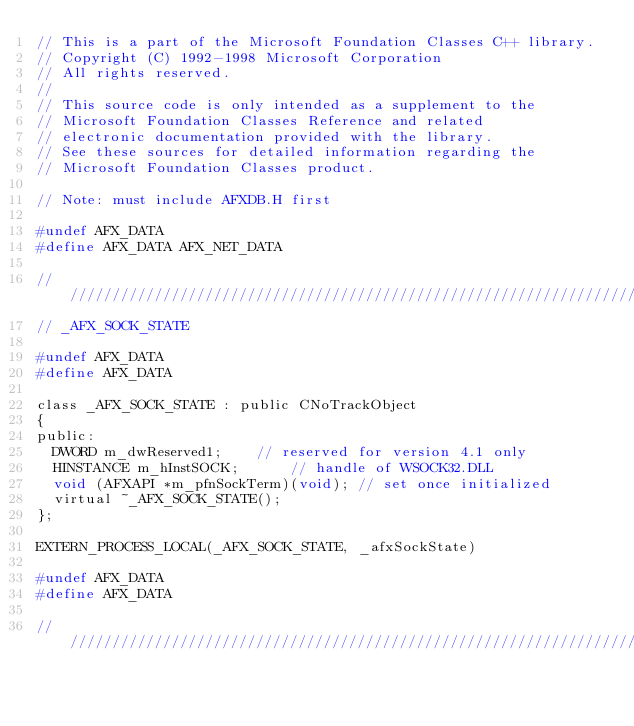<code> <loc_0><loc_0><loc_500><loc_500><_C_>// This is a part of the Microsoft Foundation Classes C++ library.
// Copyright (C) 1992-1998 Microsoft Corporation
// All rights reserved.
//
// This source code is only intended as a supplement to the
// Microsoft Foundation Classes Reference and related
// electronic documentation provided with the library.
// See these sources for detailed information regarding the
// Microsoft Foundation Classes product.

// Note: must include AFXDB.H first

#undef AFX_DATA
#define AFX_DATA AFX_NET_DATA

/////////////////////////////////////////////////////////////////////////////
// _AFX_SOCK_STATE

#undef AFX_DATA
#define AFX_DATA

class _AFX_SOCK_STATE : public CNoTrackObject
{
public:
	DWORD m_dwReserved1;    // reserved for version 4.1 only
	HINSTANCE m_hInstSOCK;      // handle of WSOCK32.DLL
	void (AFXAPI *m_pfnSockTerm)(void); // set once initialized
	virtual ~_AFX_SOCK_STATE();
};

EXTERN_PROCESS_LOCAL(_AFX_SOCK_STATE, _afxSockState)

#undef AFX_DATA
#define AFX_DATA

/////////////////////////////////////////////////////////////////////////////
</code> 